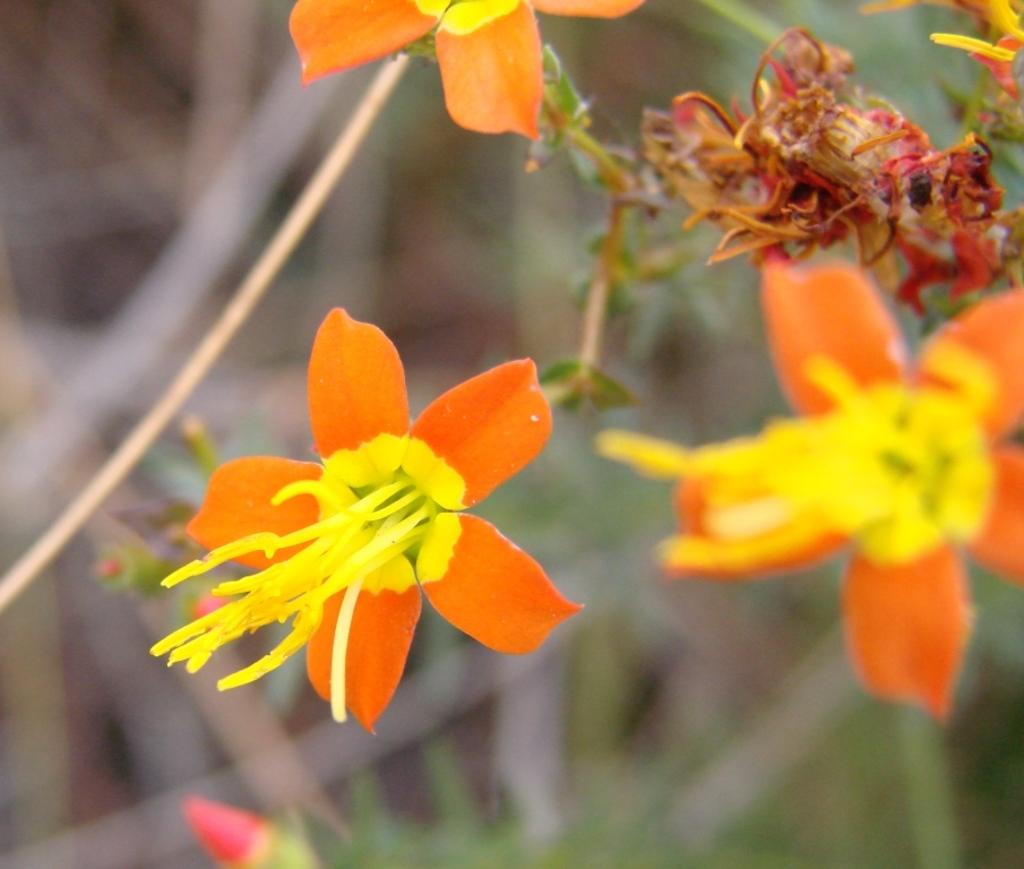What type of plants are present in the image? There are plants with flowers in the image. What colors can be seen in the flowers? The flowers are in orange and yellow colors. Can you describe the bud at the bottom of the image? The bud at the bottom of the image is pink. How would you describe the background of the image? The background of the image is blurred. How much payment is required to purchase the oranges in the image? There are no oranges present in the image, so it is not possible to determine the payment required. 